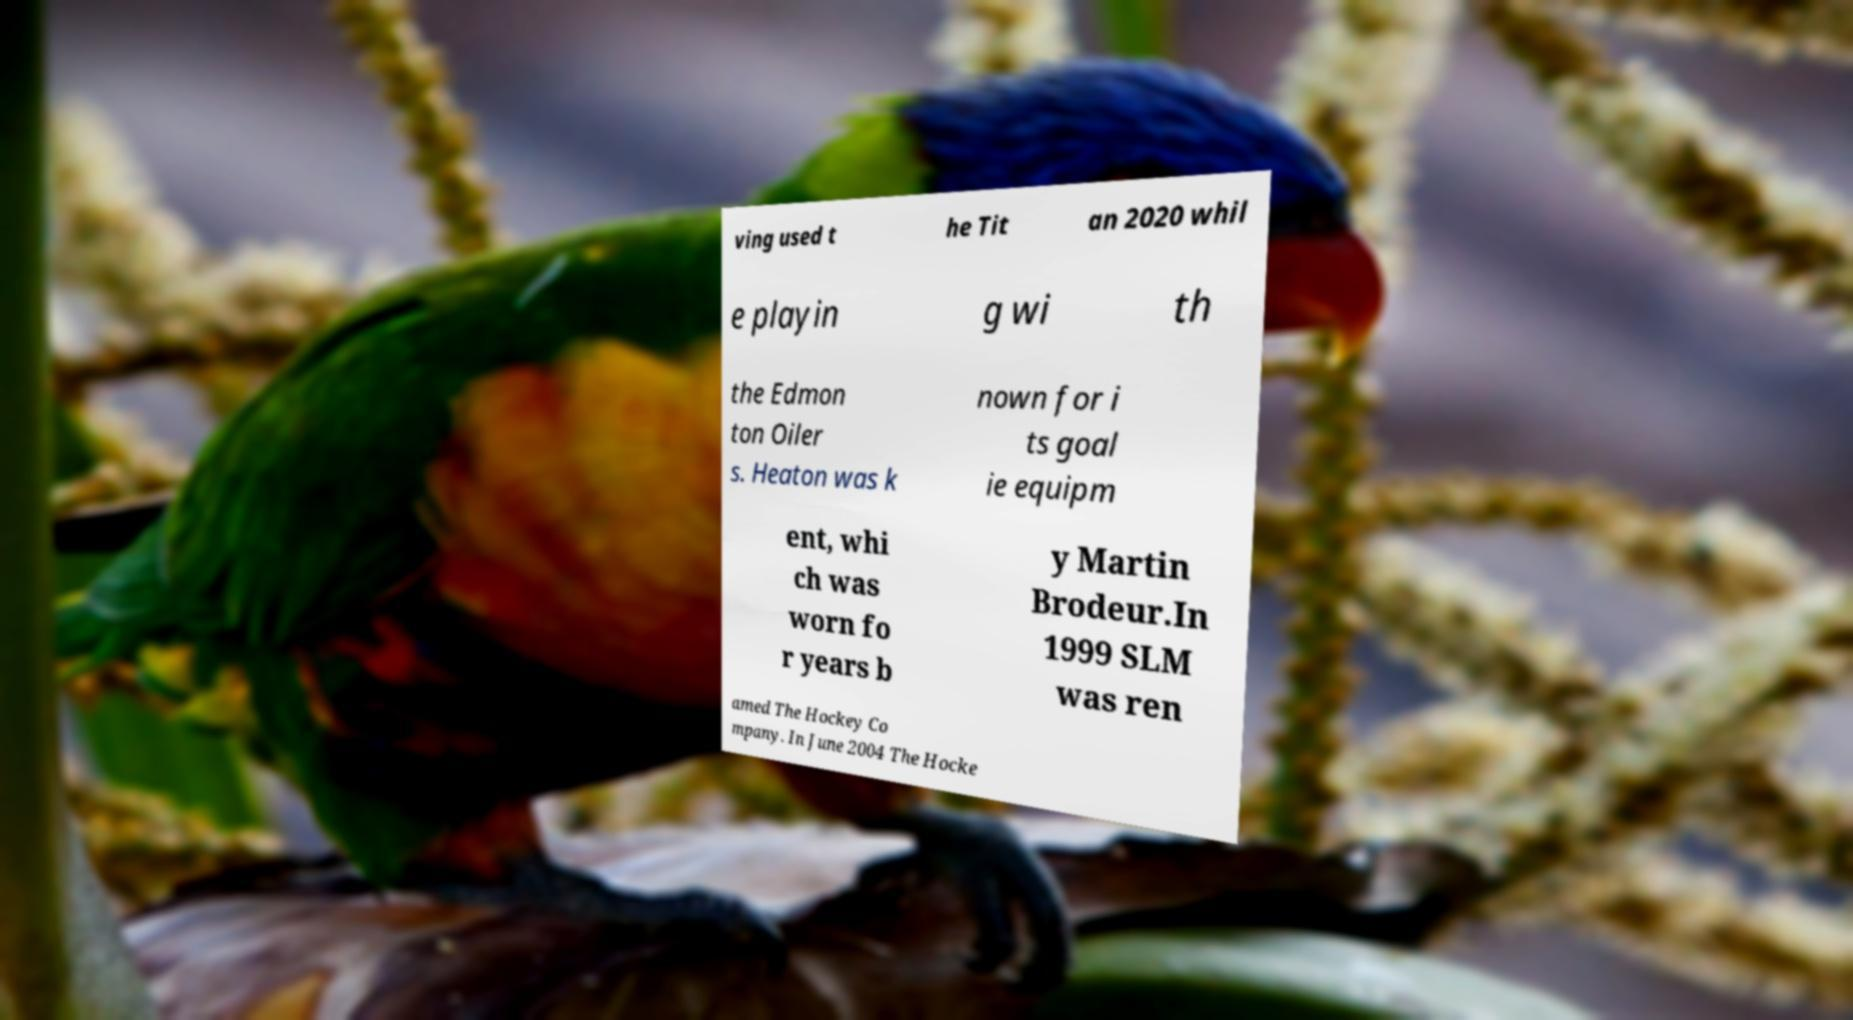What messages or text are displayed in this image? I need them in a readable, typed format. ving used t he Tit an 2020 whil e playin g wi th the Edmon ton Oiler s. Heaton was k nown for i ts goal ie equipm ent, whi ch was worn fo r years b y Martin Brodeur.In 1999 SLM was ren amed The Hockey Co mpany. In June 2004 The Hocke 